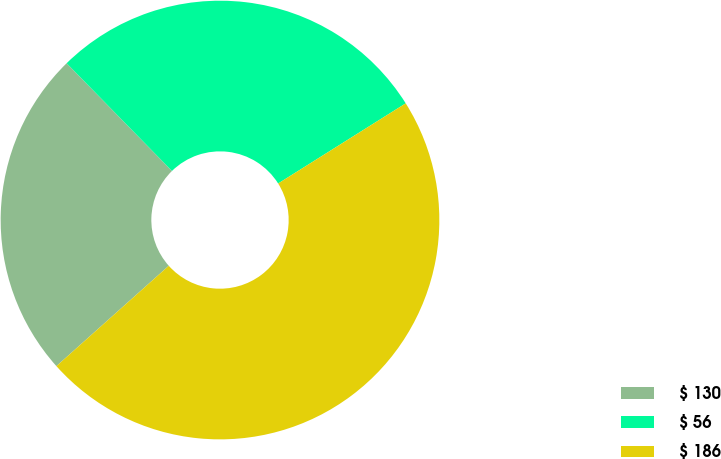<chart> <loc_0><loc_0><loc_500><loc_500><pie_chart><fcel>$ 130<fcel>$ 56<fcel>$ 186<nl><fcel>24.28%<fcel>28.4%<fcel>47.33%<nl></chart> 